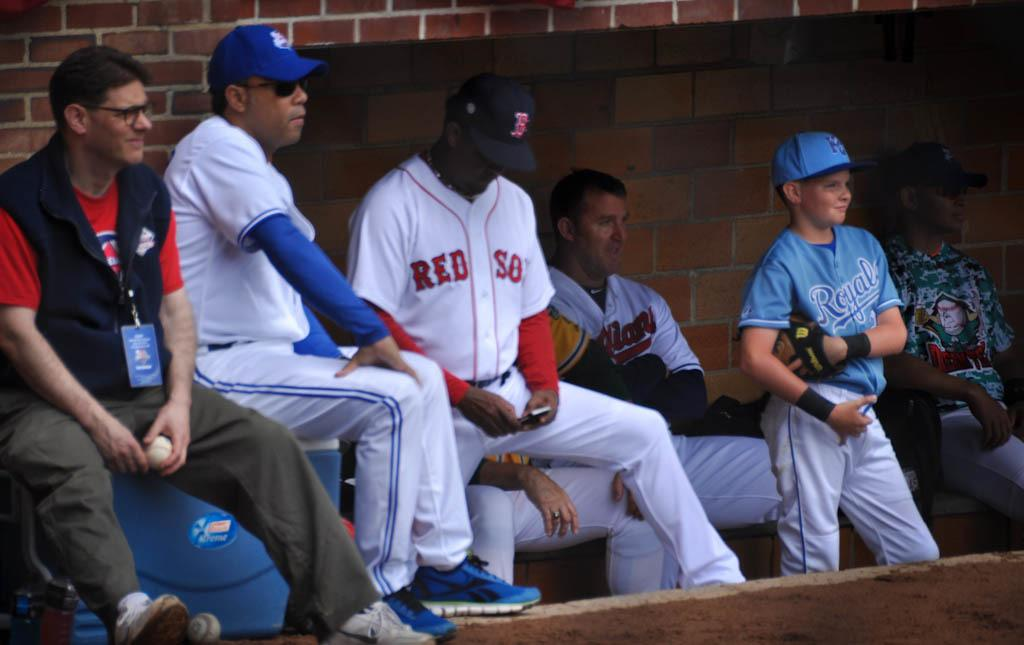Provide a one-sentence caption for the provided image. a Red Sox player is looking at his cell phone. 